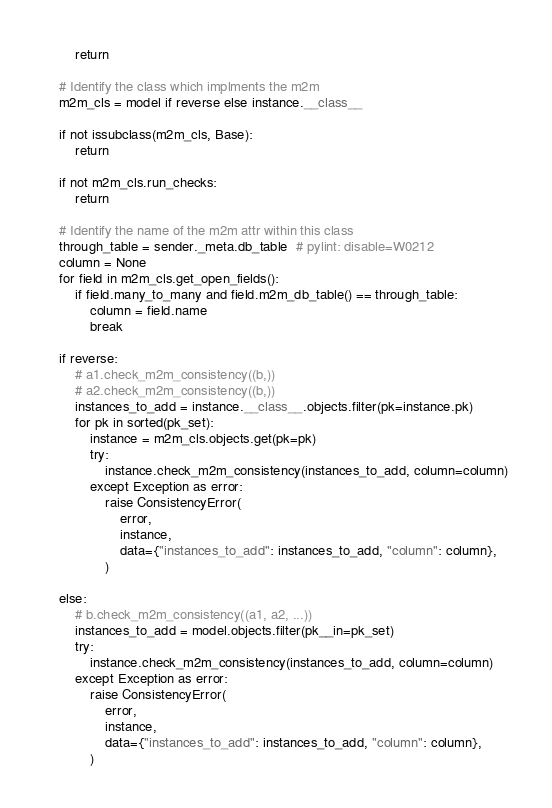Convert code to text. <code><loc_0><loc_0><loc_500><loc_500><_Python_>        return

    # Identify the class which implments the m2m
    m2m_cls = model if reverse else instance.__class__

    if not issubclass(m2m_cls, Base):
        return

    if not m2m_cls.run_checks:
        return

    # Identify the name of the m2m attr within this class
    through_table = sender._meta.db_table  # pylint: disable=W0212
    column = None
    for field in m2m_cls.get_open_fields():
        if field.many_to_many and field.m2m_db_table() == through_table:
            column = field.name
            break

    if reverse:
        # a1.check_m2m_consistency((b,))
        # a2.check_m2m_consistency((b,))
        instances_to_add = instance.__class__.objects.filter(pk=instance.pk)
        for pk in sorted(pk_set):
            instance = m2m_cls.objects.get(pk=pk)
            try:
                instance.check_m2m_consistency(instances_to_add, column=column)
            except Exception as error:
                raise ConsistencyError(
                    error,
                    instance,
                    data={"instances_to_add": instances_to_add, "column": column},
                )

    else:
        # b.check_m2m_consistency((a1, a2, ...))
        instances_to_add = model.objects.filter(pk__in=pk_set)
        try:
            instance.check_m2m_consistency(instances_to_add, column=column)
        except Exception as error:
            raise ConsistencyError(
                error,
                instance,
                data={"instances_to_add": instances_to_add, "column": column},
            )
</code> 